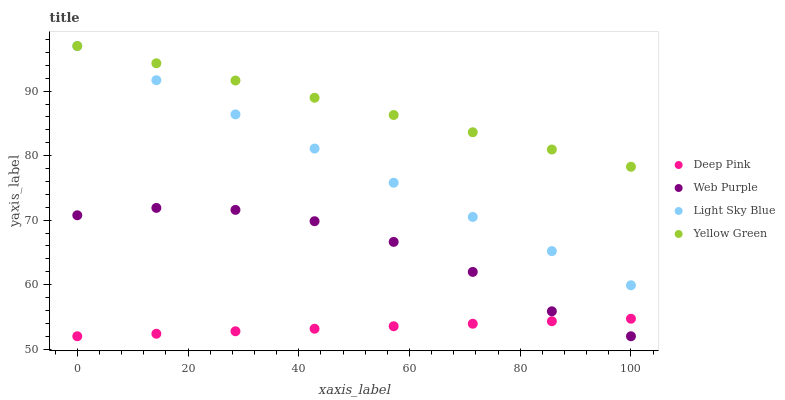Does Deep Pink have the minimum area under the curve?
Answer yes or no. Yes. Does Yellow Green have the maximum area under the curve?
Answer yes or no. Yes. Does Yellow Green have the minimum area under the curve?
Answer yes or no. No. Does Deep Pink have the maximum area under the curve?
Answer yes or no. No. Is Deep Pink the smoothest?
Answer yes or no. Yes. Is Web Purple the roughest?
Answer yes or no. Yes. Is Yellow Green the smoothest?
Answer yes or no. No. Is Yellow Green the roughest?
Answer yes or no. No. Does Web Purple have the lowest value?
Answer yes or no. Yes. Does Yellow Green have the lowest value?
Answer yes or no. No. Does Light Sky Blue have the highest value?
Answer yes or no. Yes. Does Deep Pink have the highest value?
Answer yes or no. No. Is Deep Pink less than Yellow Green?
Answer yes or no. Yes. Is Yellow Green greater than Deep Pink?
Answer yes or no. Yes. Does Yellow Green intersect Light Sky Blue?
Answer yes or no. Yes. Is Yellow Green less than Light Sky Blue?
Answer yes or no. No. Is Yellow Green greater than Light Sky Blue?
Answer yes or no. No. Does Deep Pink intersect Yellow Green?
Answer yes or no. No. 